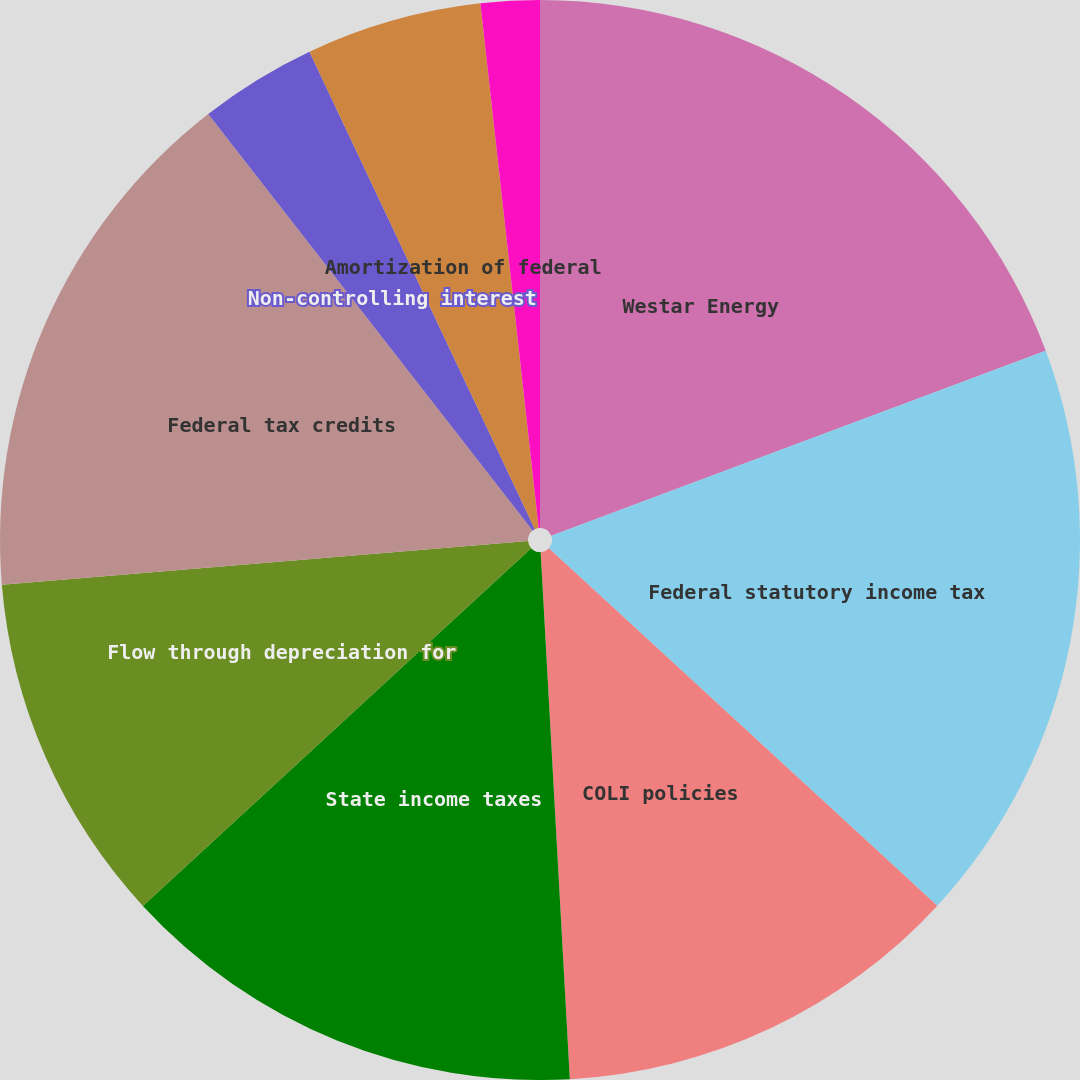Convert chart to OTSL. <chart><loc_0><loc_0><loc_500><loc_500><pie_chart><fcel>Westar Energy<fcel>Federal statutory income tax<fcel>COLI policies<fcel>State income taxes<fcel>Flow through depreciation for<fcel>Federal tax credits<fcel>Non-controlling interest<fcel>AFUDC equity<fcel>Amortization of federal<fcel>Valuation allowance<nl><fcel>19.3%<fcel>17.54%<fcel>12.28%<fcel>14.03%<fcel>10.53%<fcel>15.79%<fcel>3.51%<fcel>0.0%<fcel>5.26%<fcel>1.76%<nl></chart> 